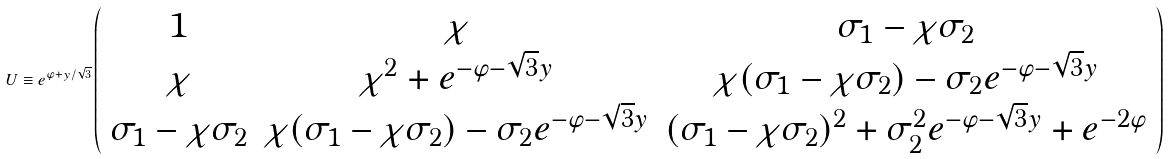<formula> <loc_0><loc_0><loc_500><loc_500>U \equiv e ^ { \varphi + y / \sqrt { 3 } } \left ( \begin{array} { c c c } { 1 } & { \chi } & { { \sigma _ { 1 } - \chi \sigma _ { 2 } } } \\ { \chi } & { { \chi ^ { 2 } + e ^ { - \varphi - \sqrt { 3 } y } } } & { { \chi ( \sigma _ { 1 } - \chi \sigma _ { 2 } ) - \sigma _ { 2 } e ^ { - \varphi - \sqrt { 3 } y } } } \\ { { \sigma _ { 1 } - \chi \sigma _ { 2 } } } & { { \chi ( \sigma _ { 1 } - \chi \sigma _ { 2 } ) - \sigma _ { 2 } e ^ { - \varphi - \sqrt { 3 } y } } } & { { ( \sigma _ { 1 } - \chi \sigma _ { 2 } ) ^ { 2 } + \sigma _ { 2 } ^ { 2 } e ^ { - \varphi - \sqrt { 3 } y } + e ^ { - 2 \varphi } } } \end{array} \right )</formula> 